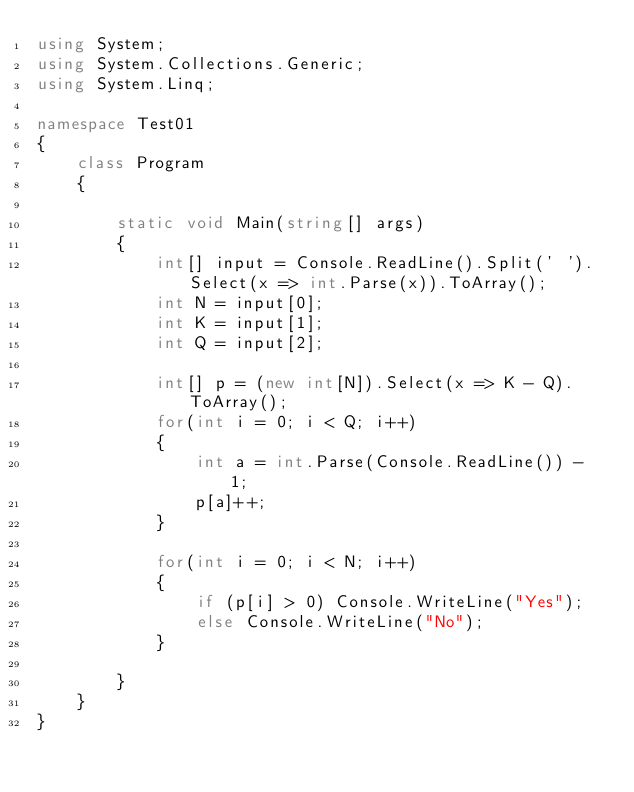<code> <loc_0><loc_0><loc_500><loc_500><_C#_>using System;
using System.Collections.Generic;
using System.Linq;

namespace Test01
{
    class Program
    {
        
        static void Main(string[] args)
        {
            int[] input = Console.ReadLine().Split(' ').Select(x => int.Parse(x)).ToArray();
            int N = input[0];
            int K = input[1];
            int Q = input[2];

            int[] p = (new int[N]).Select(x => K - Q).ToArray();
            for(int i = 0; i < Q; i++)
            {
                int a = int.Parse(Console.ReadLine()) - 1;
                p[a]++;
            }

            for(int i = 0; i < N; i++)
            {
                if (p[i] > 0) Console.WriteLine("Yes");
                else Console.WriteLine("No");
            }

        }
    }
}
</code> 